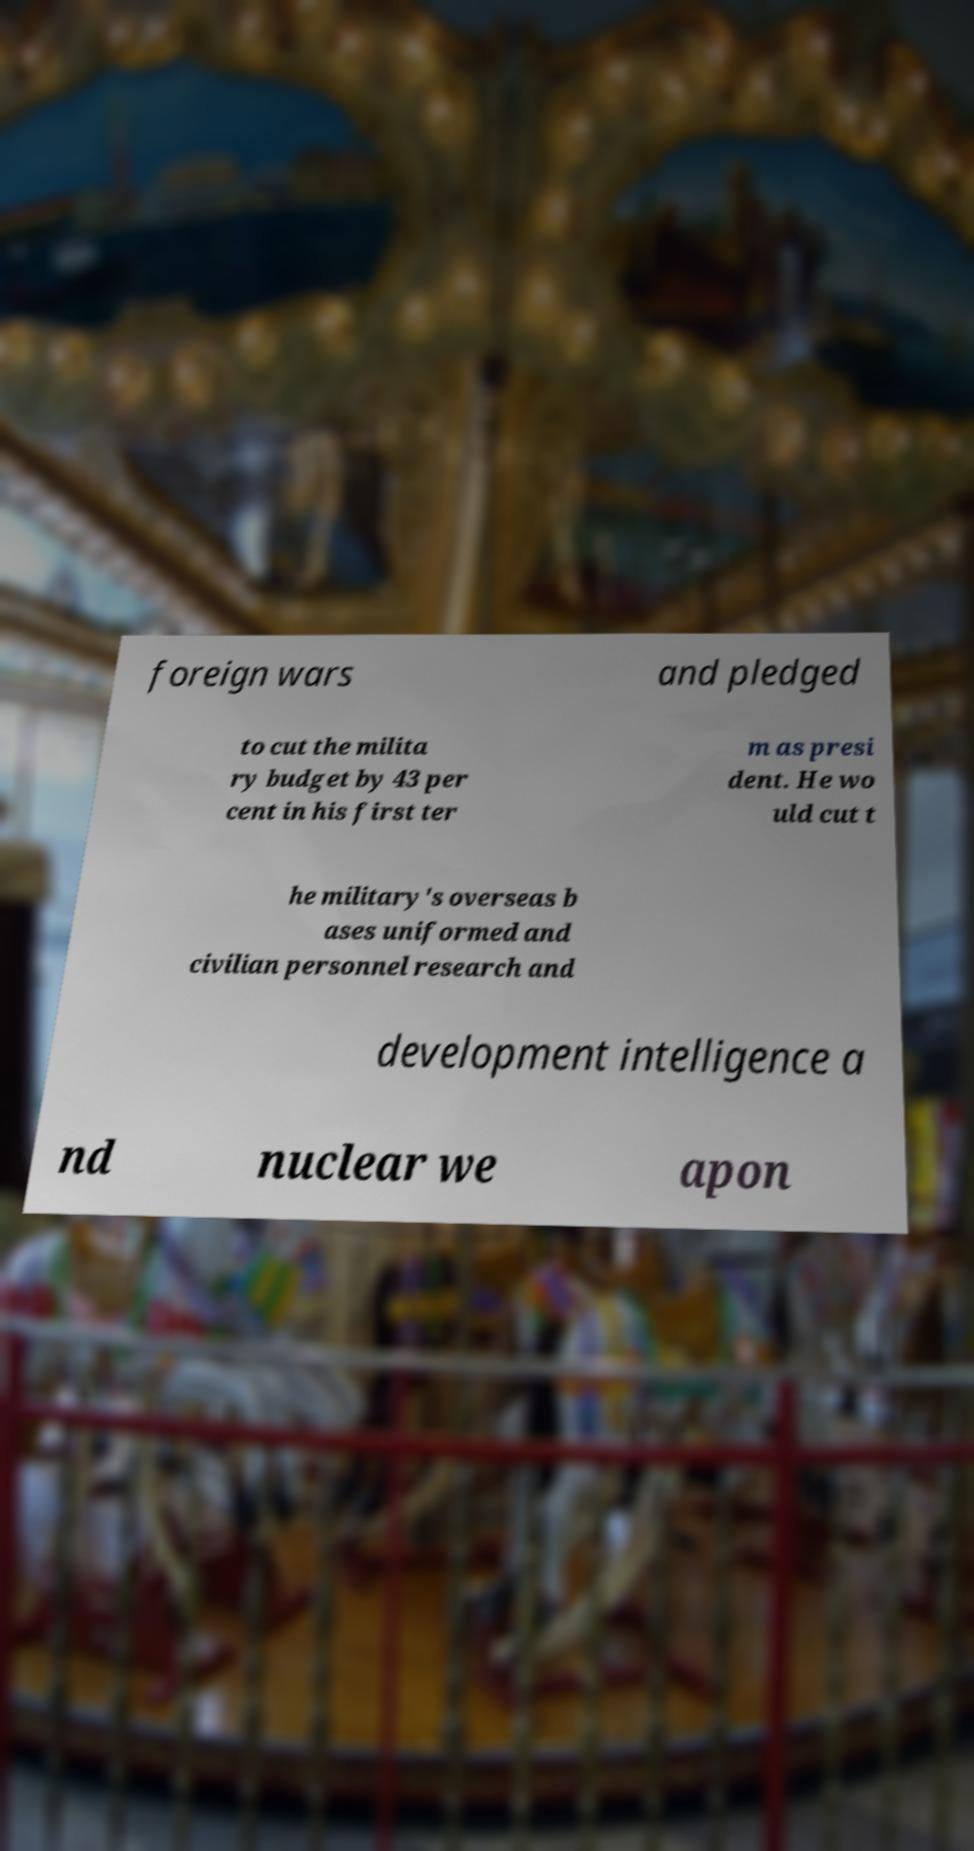For documentation purposes, I need the text within this image transcribed. Could you provide that? foreign wars and pledged to cut the milita ry budget by 43 per cent in his first ter m as presi dent. He wo uld cut t he military's overseas b ases uniformed and civilian personnel research and development intelligence a nd nuclear we apon 